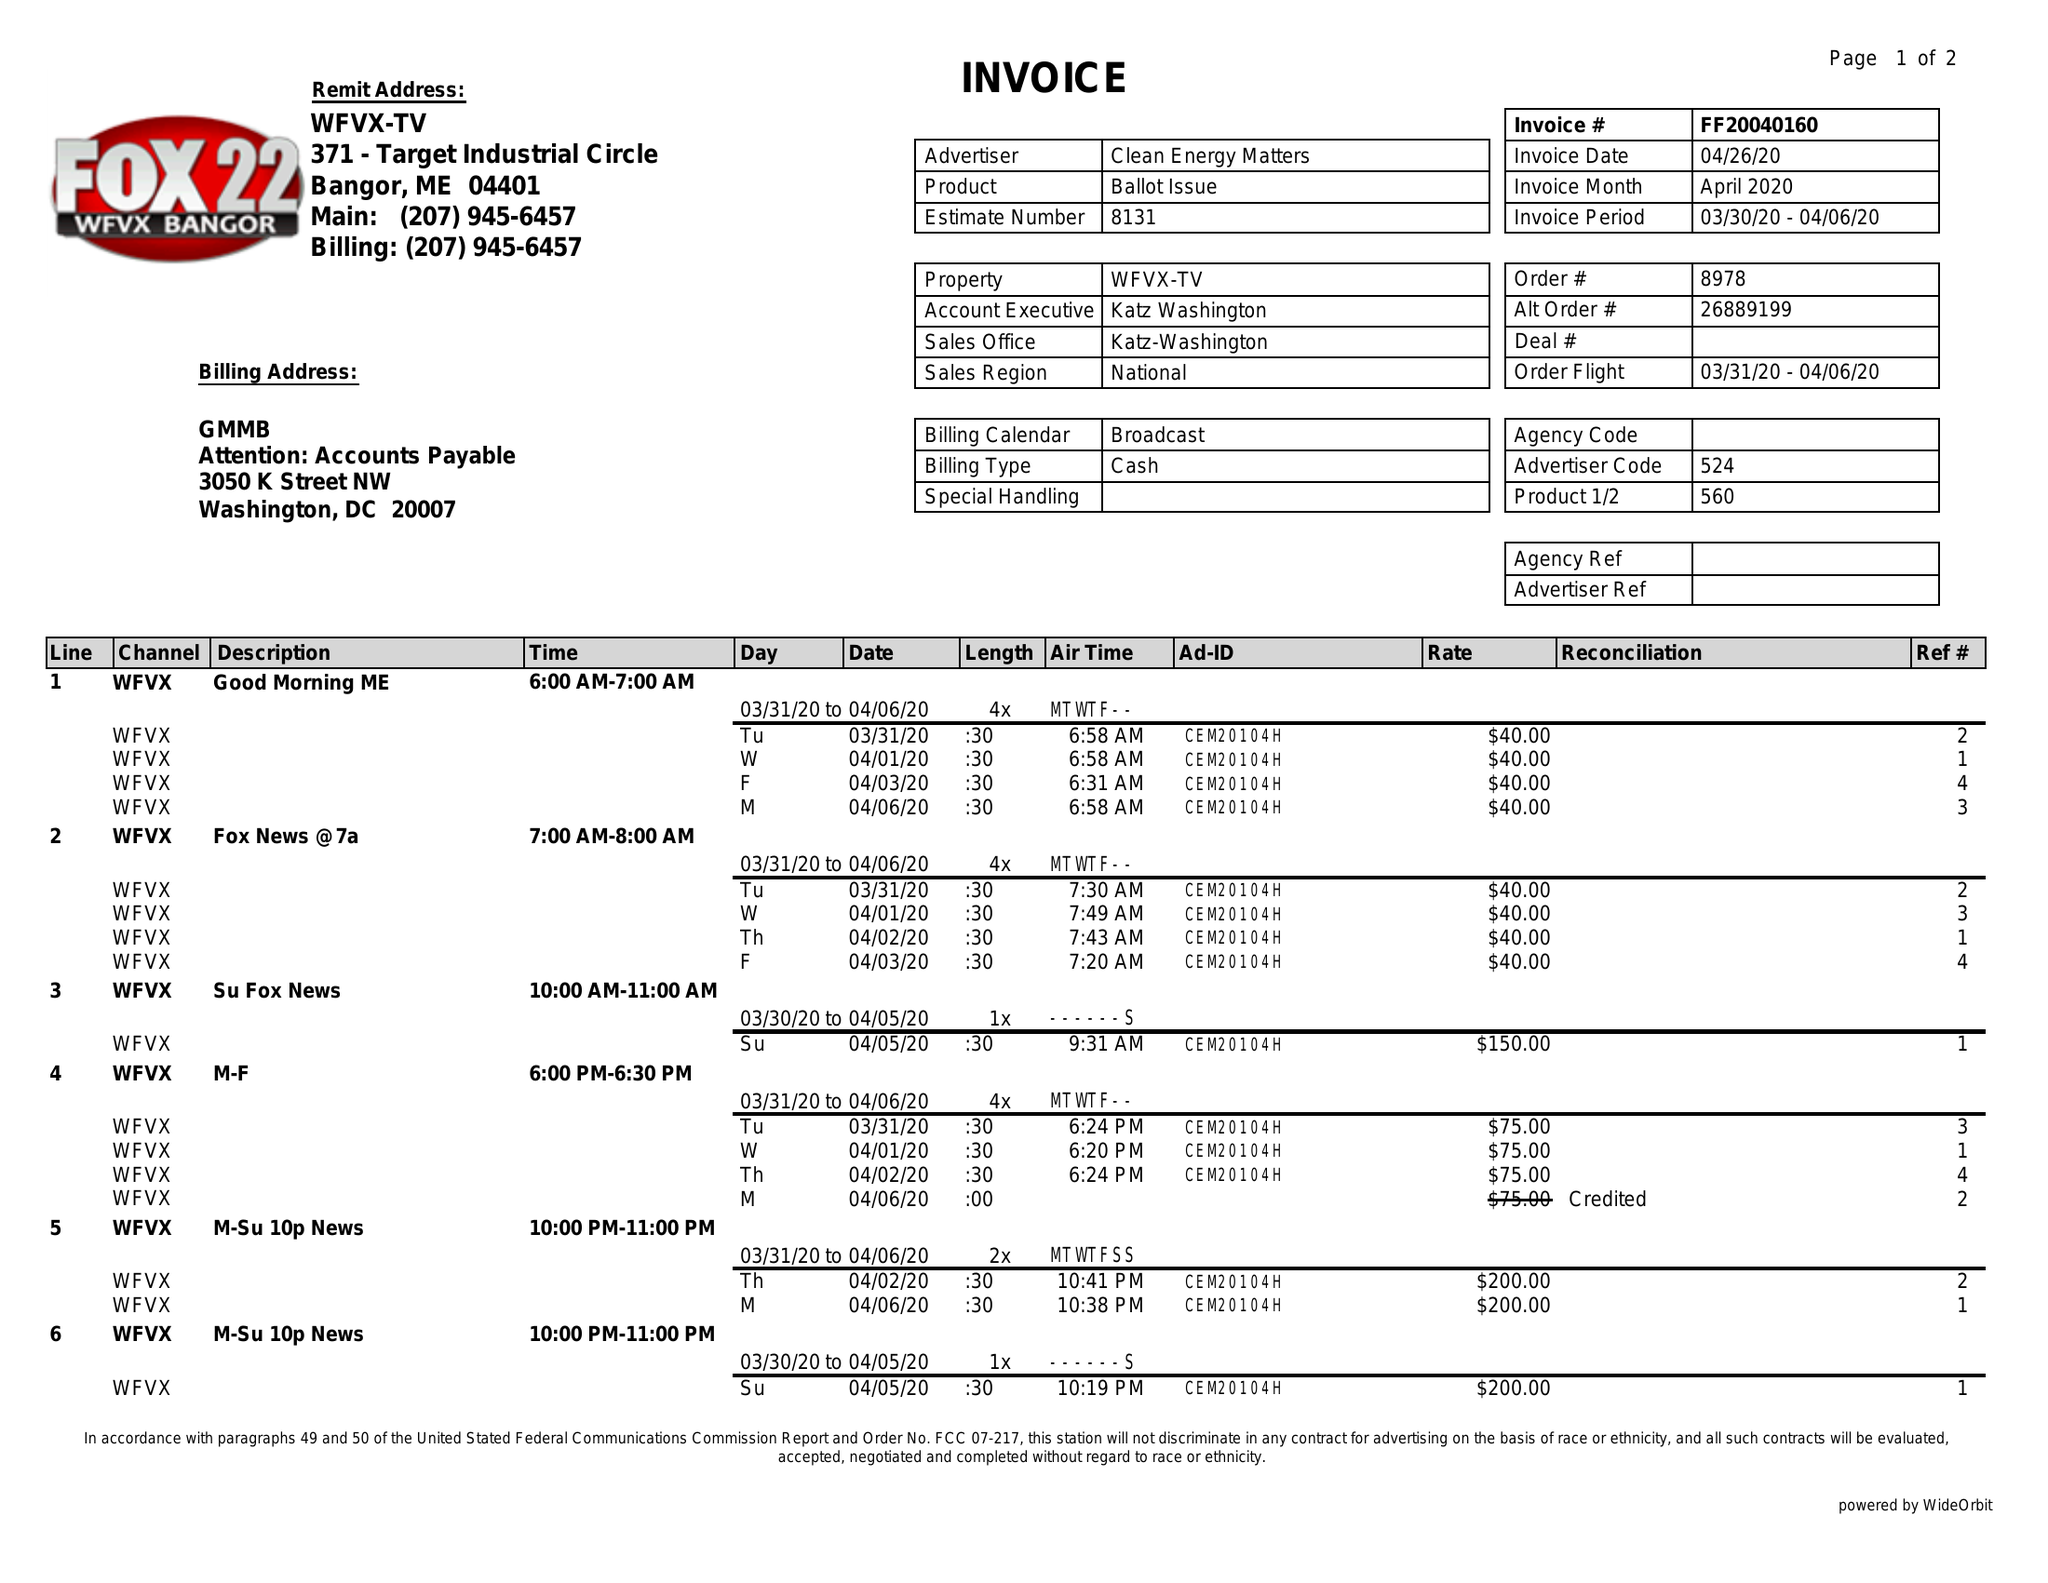What is the value for the gross_amount?
Answer the question using a single word or phrase. 1620.00 